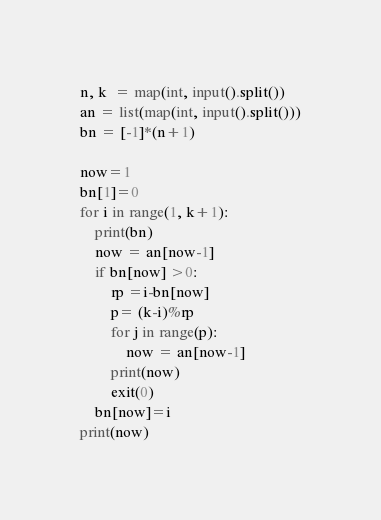<code> <loc_0><loc_0><loc_500><loc_500><_Python_>n, k  = map(int, input().split())
an = list(map(int, input().split()))
bn = [-1]*(n+1)

now=1
bn[1]=0
for i in range(1, k+1):
    print(bn)
    now = an[now-1]
    if bn[now] >0:
        rp =i-bn[now]
        p= (k-i)%rp
        for j in range(p):
            now = an[now-1]
        print(now)
        exit(0)
    bn[now]=i
print(now)</code> 